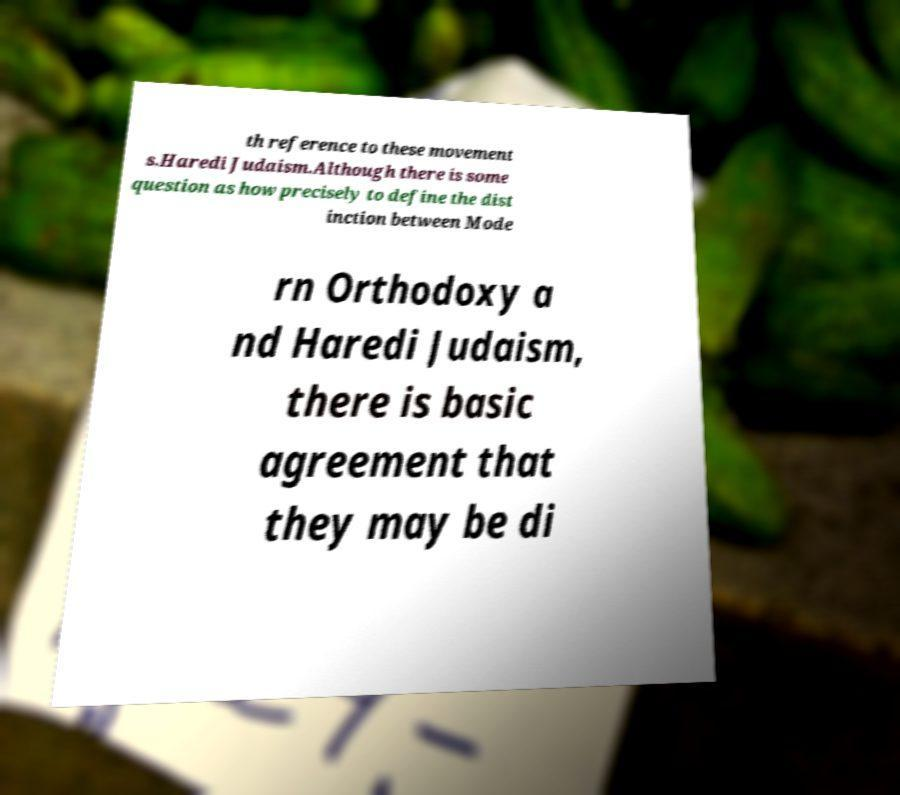Can you accurately transcribe the text from the provided image for me? th reference to these movement s.Haredi Judaism.Although there is some question as how precisely to define the dist inction between Mode rn Orthodoxy a nd Haredi Judaism, there is basic agreement that they may be di 